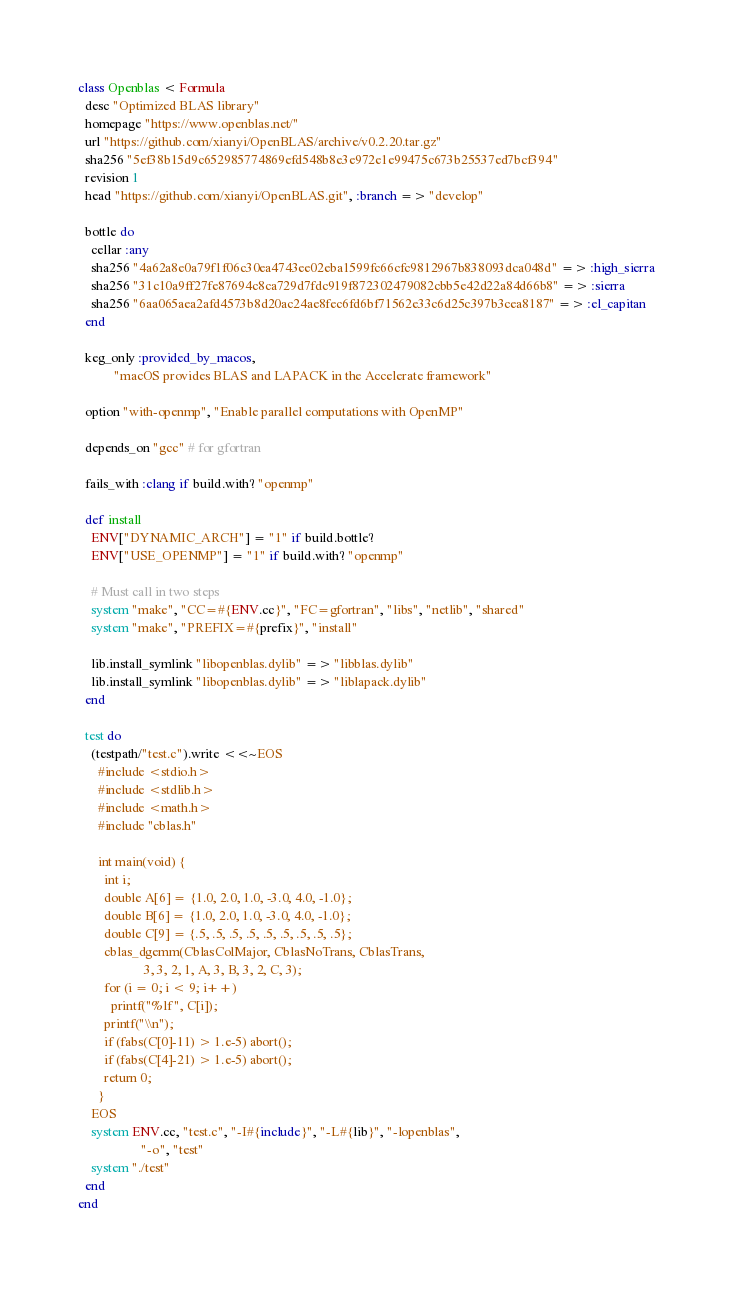Convert code to text. <code><loc_0><loc_0><loc_500><loc_500><_Ruby_>class Openblas < Formula
  desc "Optimized BLAS library"
  homepage "https://www.openblas.net/"
  url "https://github.com/xianyi/OpenBLAS/archive/v0.2.20.tar.gz"
  sha256 "5ef38b15d9c652985774869efd548b8e3e972e1e99475c673b25537ed7bcf394"
  revision 1
  head "https://github.com/xianyi/OpenBLAS.git", :branch => "develop"

  bottle do
    cellar :any
    sha256 "4a62a8e0a79f1f06c30ea4743ee02eba1599fc66cfc9812967b838093dca048d" => :high_sierra
    sha256 "31c10a9ff27fe87694c8ca729d7fdc919f872302479082cbb5e42d22a84d66b8" => :sierra
    sha256 "6aa065aea2afd4573b8d20ac24ae8fec6fd6bf71562e33c6d25c397b3cea8187" => :el_capitan
  end

  keg_only :provided_by_macos,
           "macOS provides BLAS and LAPACK in the Accelerate framework"

  option "with-openmp", "Enable parallel computations with OpenMP"

  depends_on "gcc" # for gfortran

  fails_with :clang if build.with? "openmp"

  def install
    ENV["DYNAMIC_ARCH"] = "1" if build.bottle?
    ENV["USE_OPENMP"] = "1" if build.with? "openmp"

    # Must call in two steps
    system "make", "CC=#{ENV.cc}", "FC=gfortran", "libs", "netlib", "shared"
    system "make", "PREFIX=#{prefix}", "install"

    lib.install_symlink "libopenblas.dylib" => "libblas.dylib"
    lib.install_symlink "libopenblas.dylib" => "liblapack.dylib"
  end

  test do
    (testpath/"test.c").write <<~EOS
      #include <stdio.h>
      #include <stdlib.h>
      #include <math.h>
      #include "cblas.h"

      int main(void) {
        int i;
        double A[6] = {1.0, 2.0, 1.0, -3.0, 4.0, -1.0};
        double B[6] = {1.0, 2.0, 1.0, -3.0, 4.0, -1.0};
        double C[9] = {.5, .5, .5, .5, .5, .5, .5, .5, .5};
        cblas_dgemm(CblasColMajor, CblasNoTrans, CblasTrans,
                    3, 3, 2, 1, A, 3, B, 3, 2, C, 3);
        for (i = 0; i < 9; i++)
          printf("%lf ", C[i]);
        printf("\\n");
        if (fabs(C[0]-11) > 1.e-5) abort();
        if (fabs(C[4]-21) > 1.e-5) abort();
        return 0;
      }
    EOS
    system ENV.cc, "test.c", "-I#{include}", "-L#{lib}", "-lopenblas",
                   "-o", "test"
    system "./test"
  end
end
</code> 